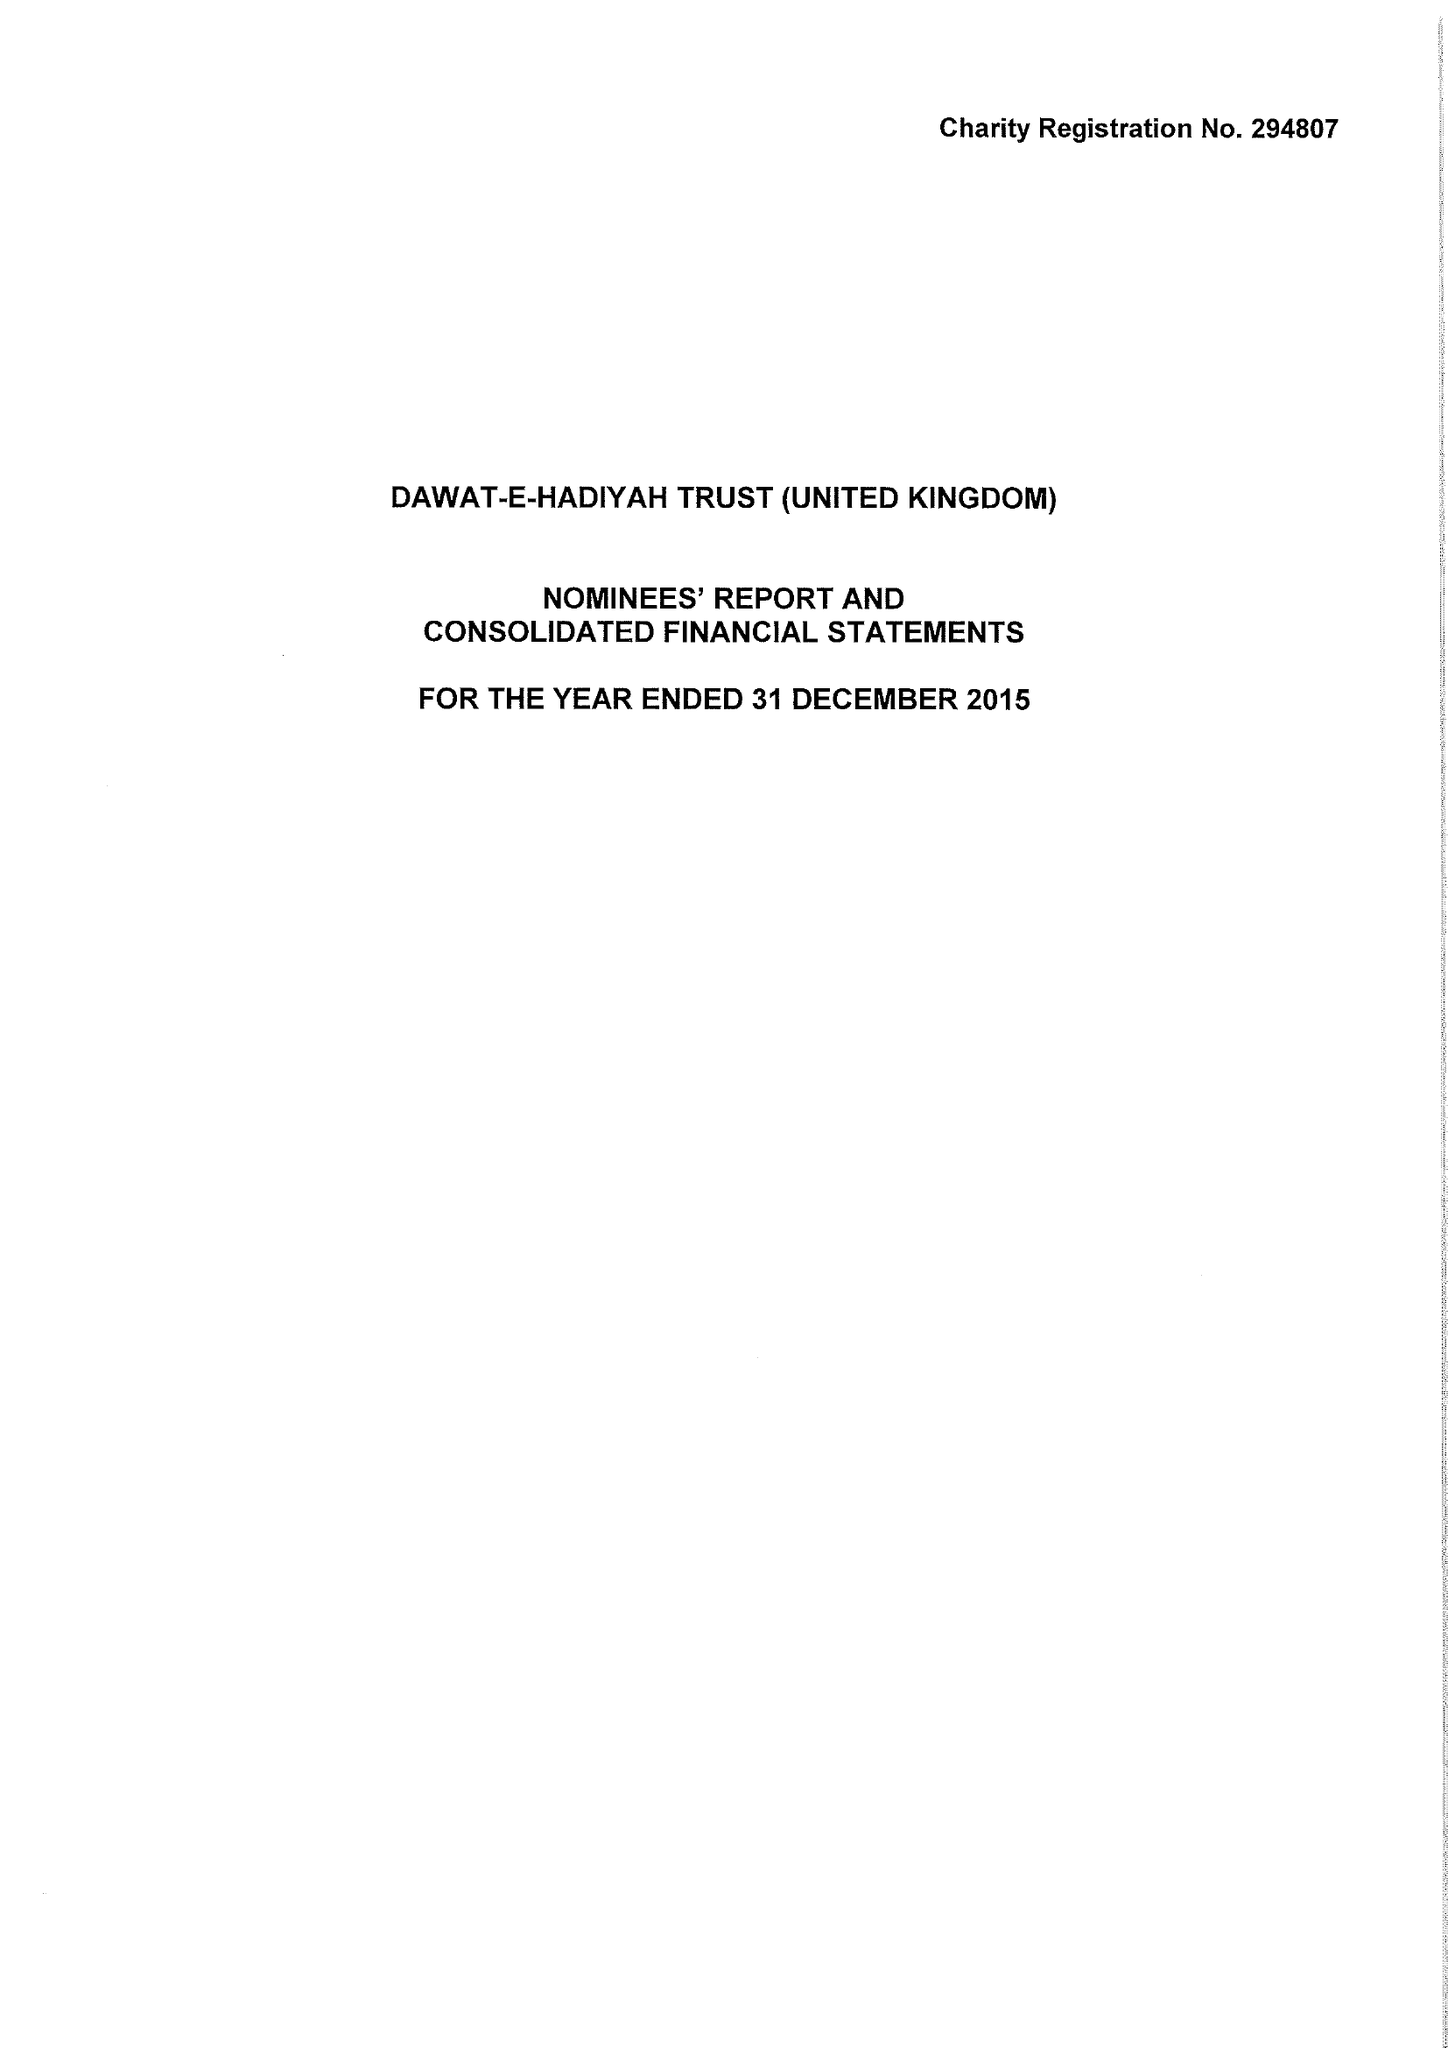What is the value for the address__street_line?
Answer the question using a single word or phrase. ROWDELL ROAD 